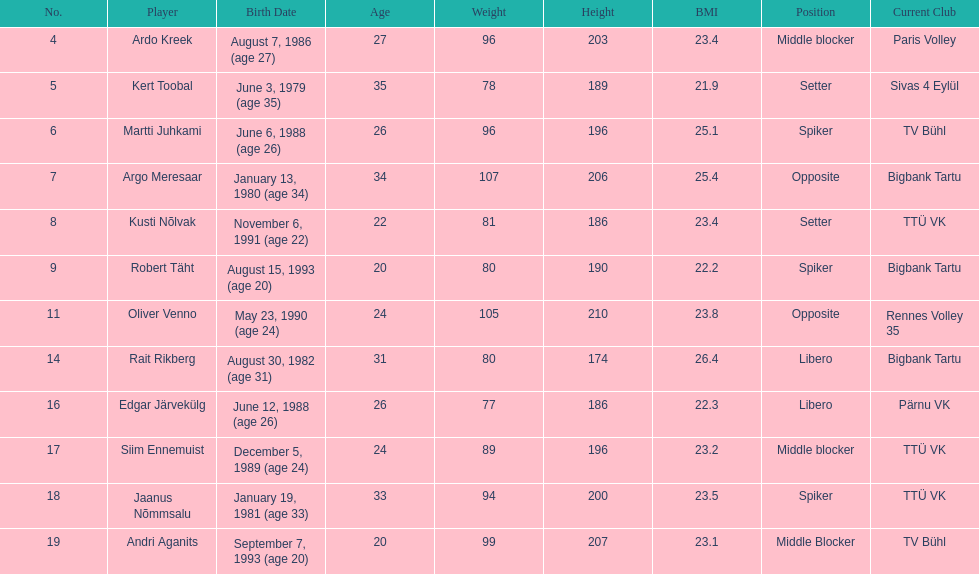How many members of estonia's men's national volleyball team were born in 1988? 2. 